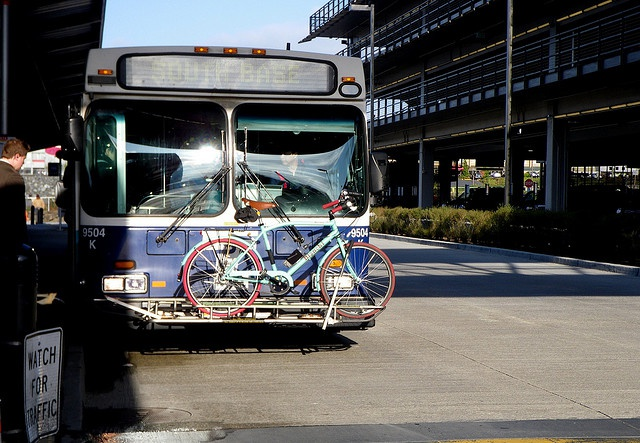Describe the objects in this image and their specific colors. I can see bus in black, darkgray, gray, and white tones, bicycle in black, white, darkgray, and gray tones, people in black, maroon, and salmon tones, people in black, darkgray, gray, and lightgray tones, and people in black and tan tones in this image. 